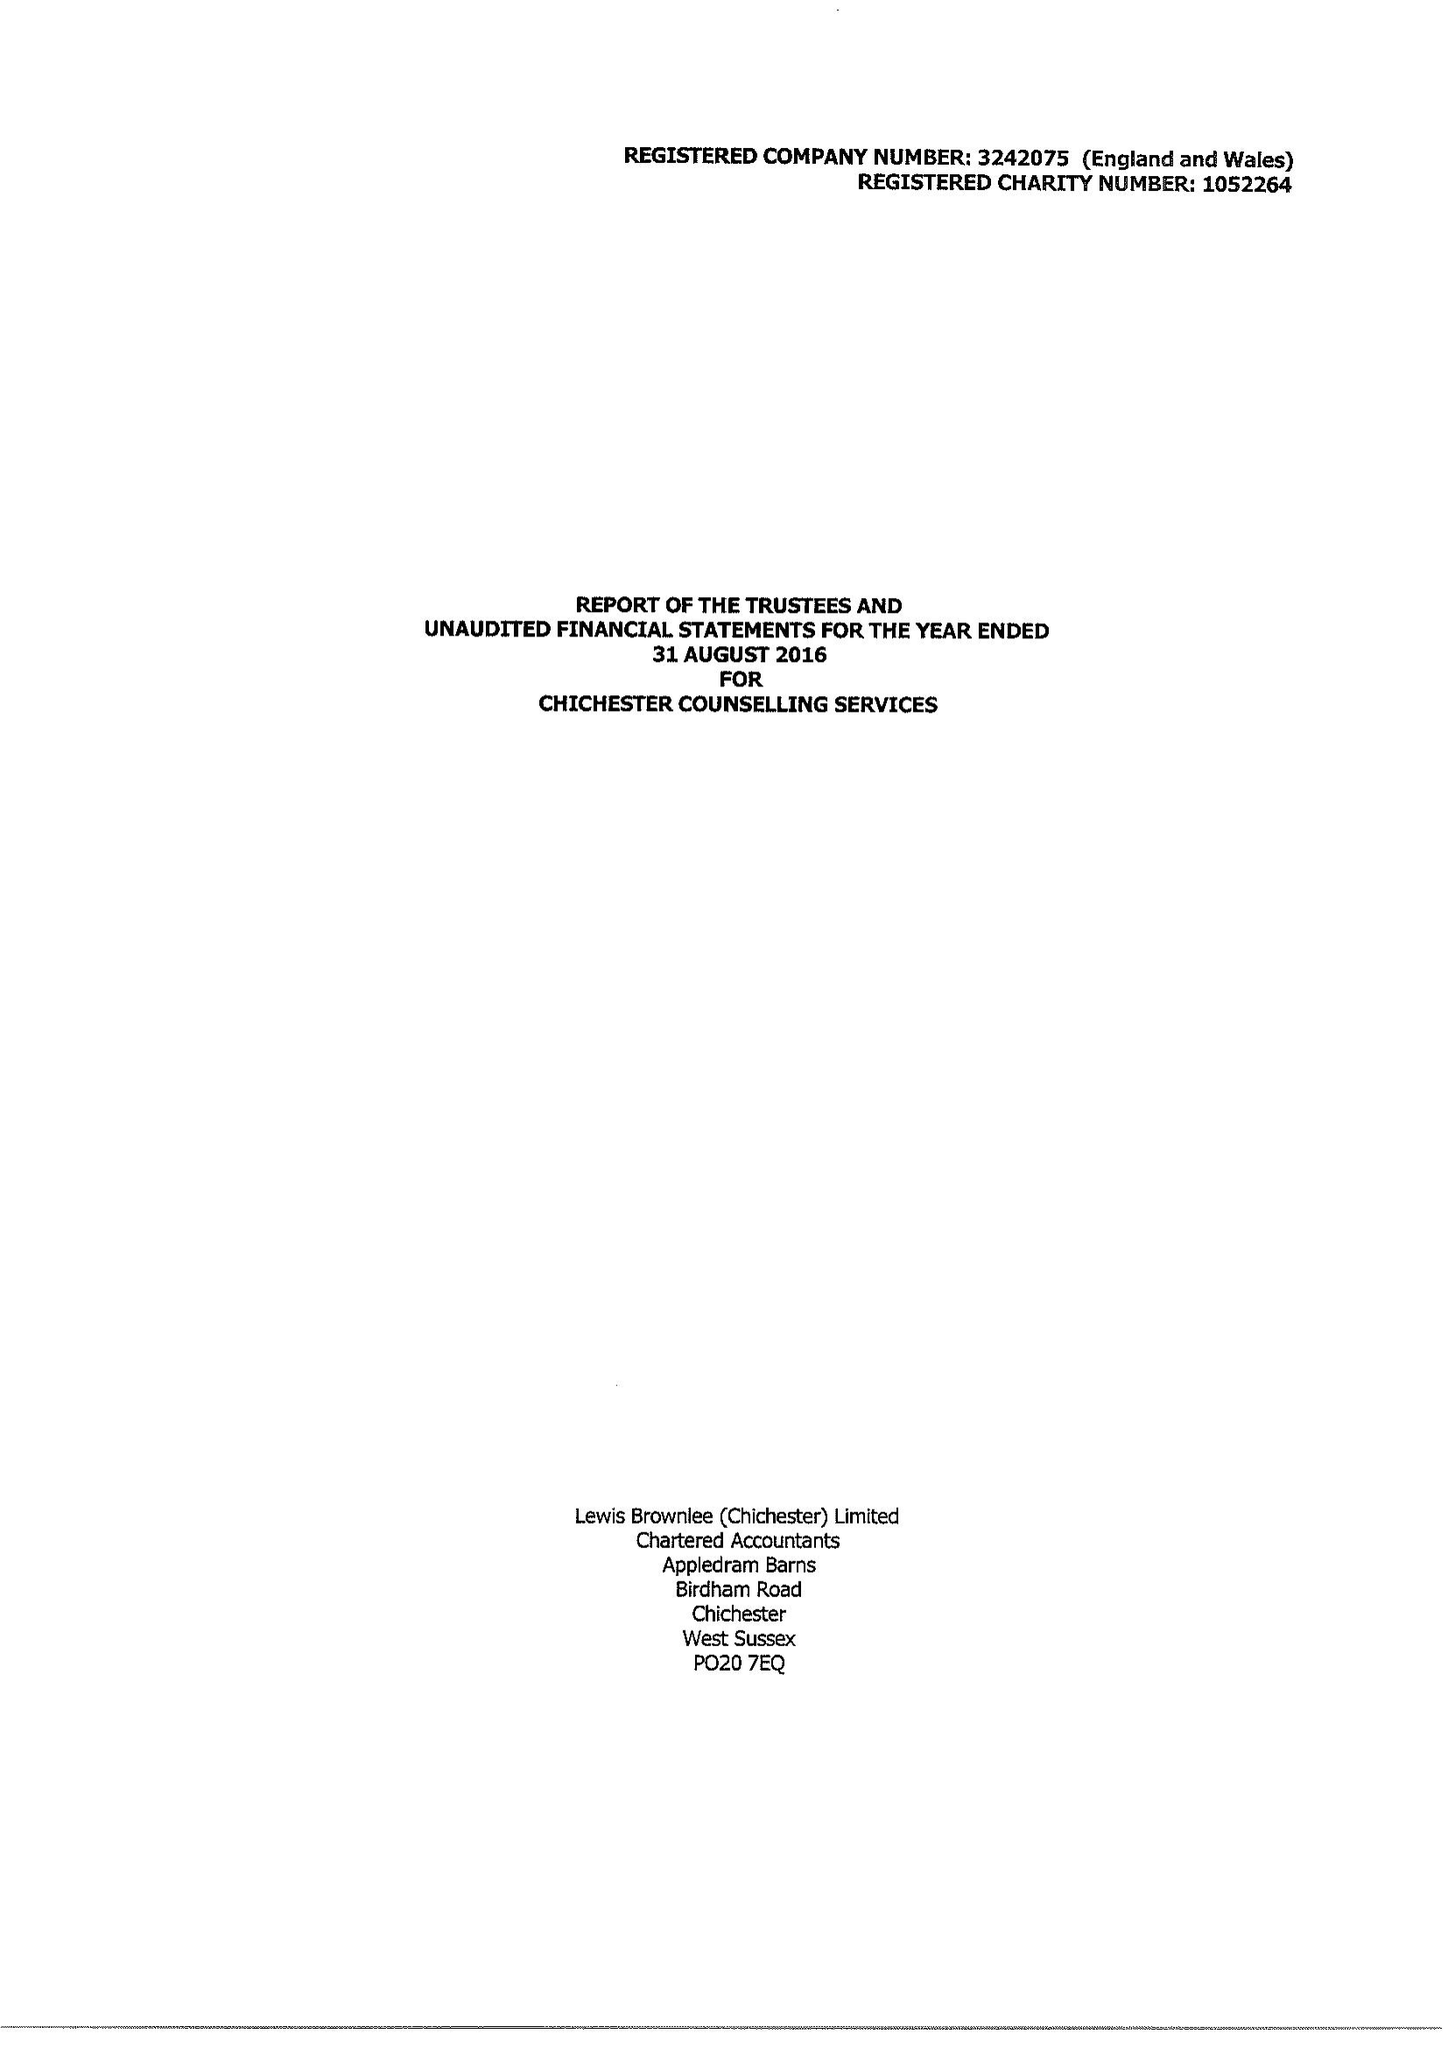What is the value for the charity_name?
Answer the question using a single word or phrase. Chichester Counselling Services 